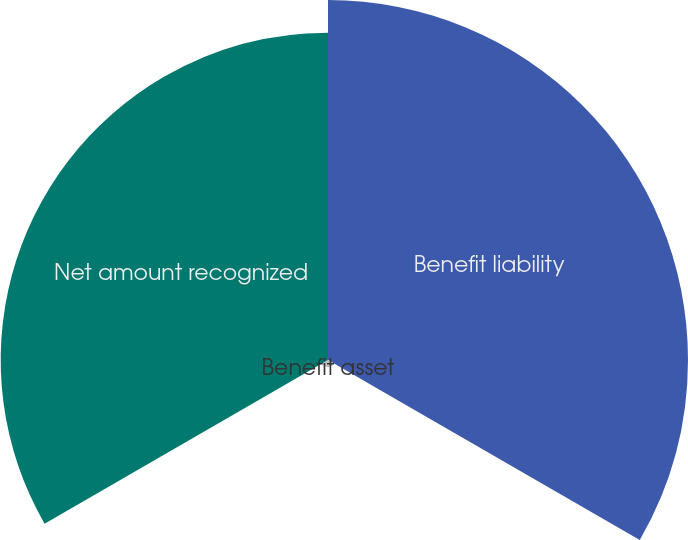Convert chart. <chart><loc_0><loc_0><loc_500><loc_500><pie_chart><fcel>Benefit liability<fcel>Benefit asset<fcel>Net amount recognized<nl><fcel>51.85%<fcel>1.01%<fcel>47.14%<nl></chart> 